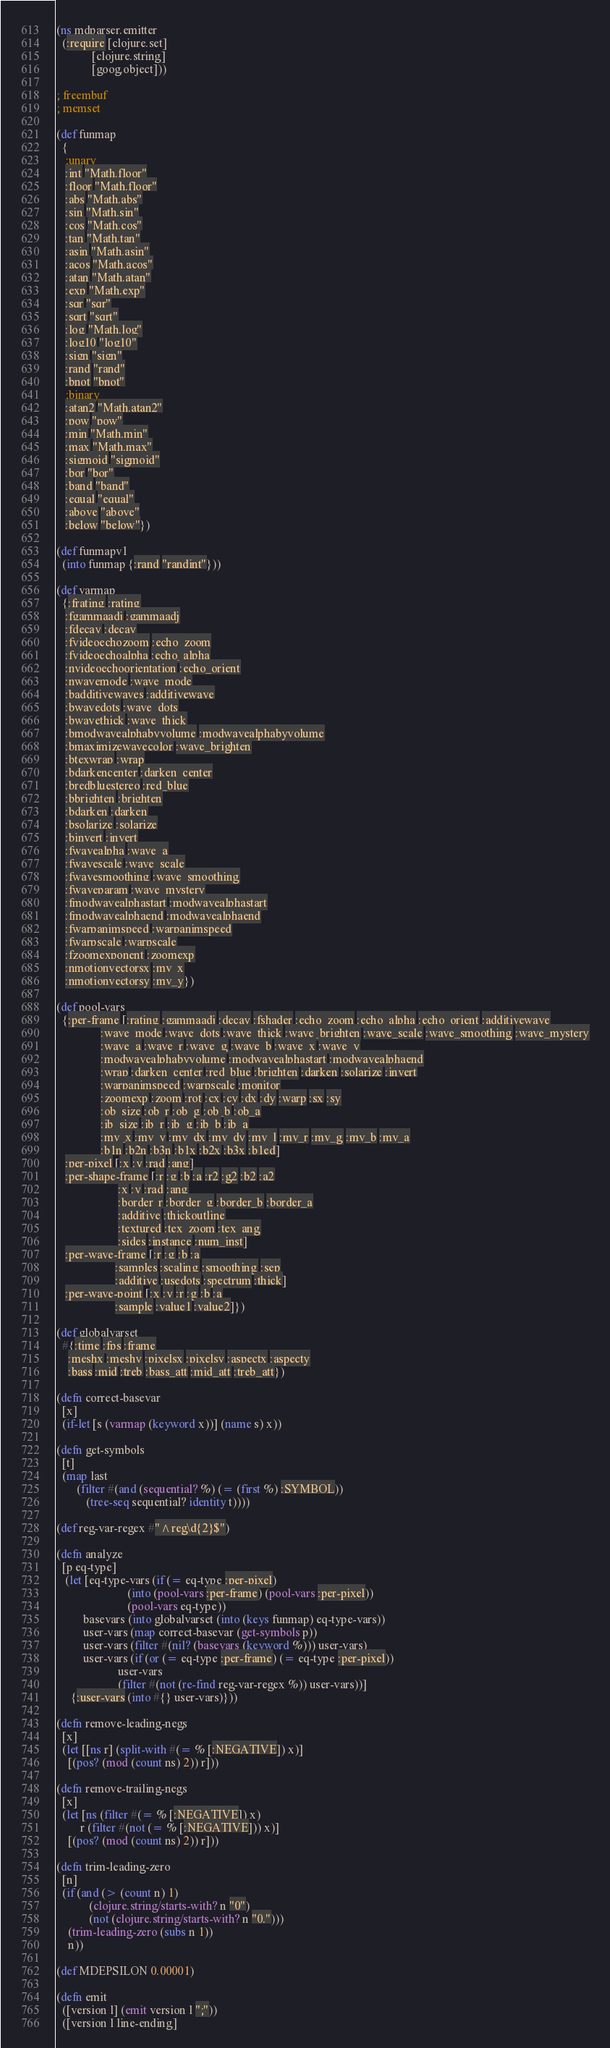Convert code to text. <code><loc_0><loc_0><loc_500><loc_500><_Clojure_>(ns mdparser.emitter
  (:require [clojure.set]
            [clojure.string]
            [goog.object]))

; freembuf
; memset

(def funmap
  {
   ;unary
   :int "Math.floor"
   :floor "Math.floor"
   :abs "Math.abs"
   :sin "Math.sin"
   :cos "Math.cos"
   :tan "Math.tan"
   :asin "Math.asin"
   :acos "Math.acos"
   :atan "Math.atan"
   :exp "Math.exp"
   :sqr "sqr"
   :sqrt "sqrt"
   :log "Math.log"
   :log10 "log10"
   :sign "sign"
   :rand "rand"
   :bnot "bnot"
   ;binary
   :atan2 "Math.atan2"
   :pow "pow"
   :min "Math.min"
   :max "Math.max"
   :sigmoid "sigmoid"
   :bor "bor"
   :band "band"
   :equal "equal"
   :above "above"
   :below "below"})

(def funmapv1
  (into funmap {:rand "randint"}))

(def varmap
  {:frating :rating
   :fgammaadj :gammaadj
   :fdecay :decay
   :fvideoechozoom :echo_zoom
   :fvideoechoalpha :echo_alpha
   :nvideoechoorientation :echo_orient
   :nwavemode :wave_mode
   :badditivewaves :additivewave
   :bwavedots :wave_dots
   :bwavethick :wave_thick
   :bmodwavealphabyvolume :modwavealphabyvolume
   :bmaximizewavecolor :wave_brighten
   :btexwrap :wrap
   :bdarkencenter :darken_center
   :bredbluestereo :red_blue
   :bbrighten :brighten
   :bdarken :darken
   :bsolarize :solarize
   :binvert :invert
   :fwavealpha :wave_a
   :fwavescale :wave_scale
   :fwavesmoothing :wave_smoothing
   :fwaveparam :wave_mystery
   :fmodwavealphastart :modwavealphastart
   :fmodwavealphaend :modwavealphaend
   :fwarpanimspeed :warpanimspeed
   :fwarpscale :warpscale
   :fzoomexponent :zoomexp
   :nmotionvectorsx :mv_x
   :nmotionvectorsy :mv_y})

(def pool-vars
  {:per-frame [:rating :gammaadj :decay :fshader :echo_zoom :echo_alpha :echo_orient :additivewave
               :wave_mode :wave_dots :wave_thick :wave_brighten :wave_scale :wave_smoothing :wave_mystery
               :wave_a :wave_r :wave_g :wave_b :wave_x :wave_y
               :modwavealphabyvolume :modwavealphastart :modwavealphaend
               :wrap :darken_center :red_blue :brighten :darken :solarize :invert
               :warpanimspeed :warpscale :monitor
               :zoomexp :zoom :rot :cx :cy :dx :dy :warp :sx :sy
               :ob_size :ob_r :ob_g :ob_b :ob_a
               :ib_size :ib_r :ib_g :ib_b :ib_a
               :mv_x :mv_y :mv_dx :mv_dy :mv_l :mv_r :mv_g :mv_b :mv_a
               :b1n :b2n :b3n :b1x :b2x :b3x :b1ed]
   :per-pixel [:x :y :rad :ang]
   :per-shape-frame [:r :g :b :a :r2 :g2 :b2 :a2
                     :x :y :rad :ang
                     :border_r :border_g :border_b :border_a
                     :additive :thickoutline
                     :textured :tex_zoom :tex_ang
                     :sides :instance :num_inst]
   :per-wave-frame [:r :g :b :a
                    :samples :scaling :smoothing :sep
                    :additive :usedots :spectrum :thick]
   :per-wave-point [:x :y :r :g :b :a
                    :sample :value1 :value2]})

(def globalvarset
  #{:time :fps :frame
    :meshx :meshy :pixelsx :pixelsy :aspectx :aspecty
    :bass :mid :treb :bass_att :mid_att :treb_att})

(defn correct-basevar
  [x]
  (if-let [s (varmap (keyword x))] (name s) x))

(defn get-symbols
  [t]
  (map last
       (filter #(and (sequential? %) (= (first %) :SYMBOL))
          (tree-seq sequential? identity t))))

(def reg-var-regex #"^reg\d{2}$")

(defn analyze
  [p eq-type]
   (let [eq-type-vars (if (= eq-type :per-pixel)
                        (into (pool-vars :per-frame) (pool-vars :per-pixel))
                        (pool-vars eq-type))
         basevars (into globalvarset (into (keys funmap) eq-type-vars))
         user-vars (map correct-basevar (get-symbols p))
         user-vars (filter #(nil? (basevars (keyword %))) user-vars)
         user-vars (if (or (= eq-type :per-frame) (= eq-type :per-pixel))
                     user-vars
                     (filter #(not (re-find reg-var-regex %)) user-vars))]
     {:user-vars (into #{} user-vars)}))

(defn remove-leading-negs
  [x]
  (let [[ns r] (split-with #(= % [:NEGATIVE]) x)]
    [(pos? (mod (count ns) 2)) r]))

(defn remove-trailing-negs
  [x]
  (let [ns (filter #(= % [:NEGATIVE]) x)
        r (filter #(not (= % [:NEGATIVE])) x)]
    [(pos? (mod (count ns) 2)) r]))

(defn trim-leading-zero
  [n]
  (if (and (> (count n) 1)
           (clojure.string/starts-with? n "0")
           (not (clojure.string/starts-with? n "0.")))
    (trim-leading-zero (subs n 1))
    n))

(def MDEPSILON 0.00001)

(defn emit
  ([version l] (emit version l ";"))
  ([version l line-ending]</code> 